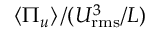<formula> <loc_0><loc_0><loc_500><loc_500>\left \langle \Pi _ { u } \right \rangle / ( U _ { r m s } ^ { 3 } / L )</formula> 